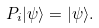<formula> <loc_0><loc_0><loc_500><loc_500>P _ { i } | \psi \rangle = | \psi \rangle .</formula> 